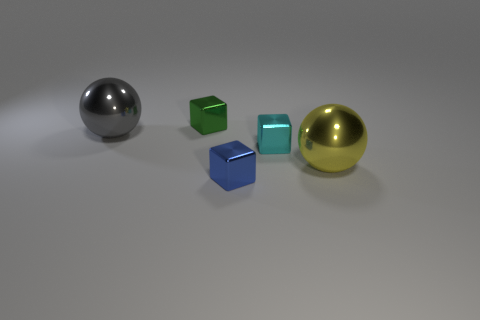Subtract 1 cubes. How many cubes are left? 2 Add 2 small gray objects. How many objects exist? 7 Subtract all blocks. How many objects are left? 2 Subtract 1 gray spheres. How many objects are left? 4 Subtract all cyan blocks. Subtract all big yellow cubes. How many objects are left? 4 Add 5 large yellow spheres. How many large yellow spheres are left? 6 Add 3 small gray things. How many small gray things exist? 3 